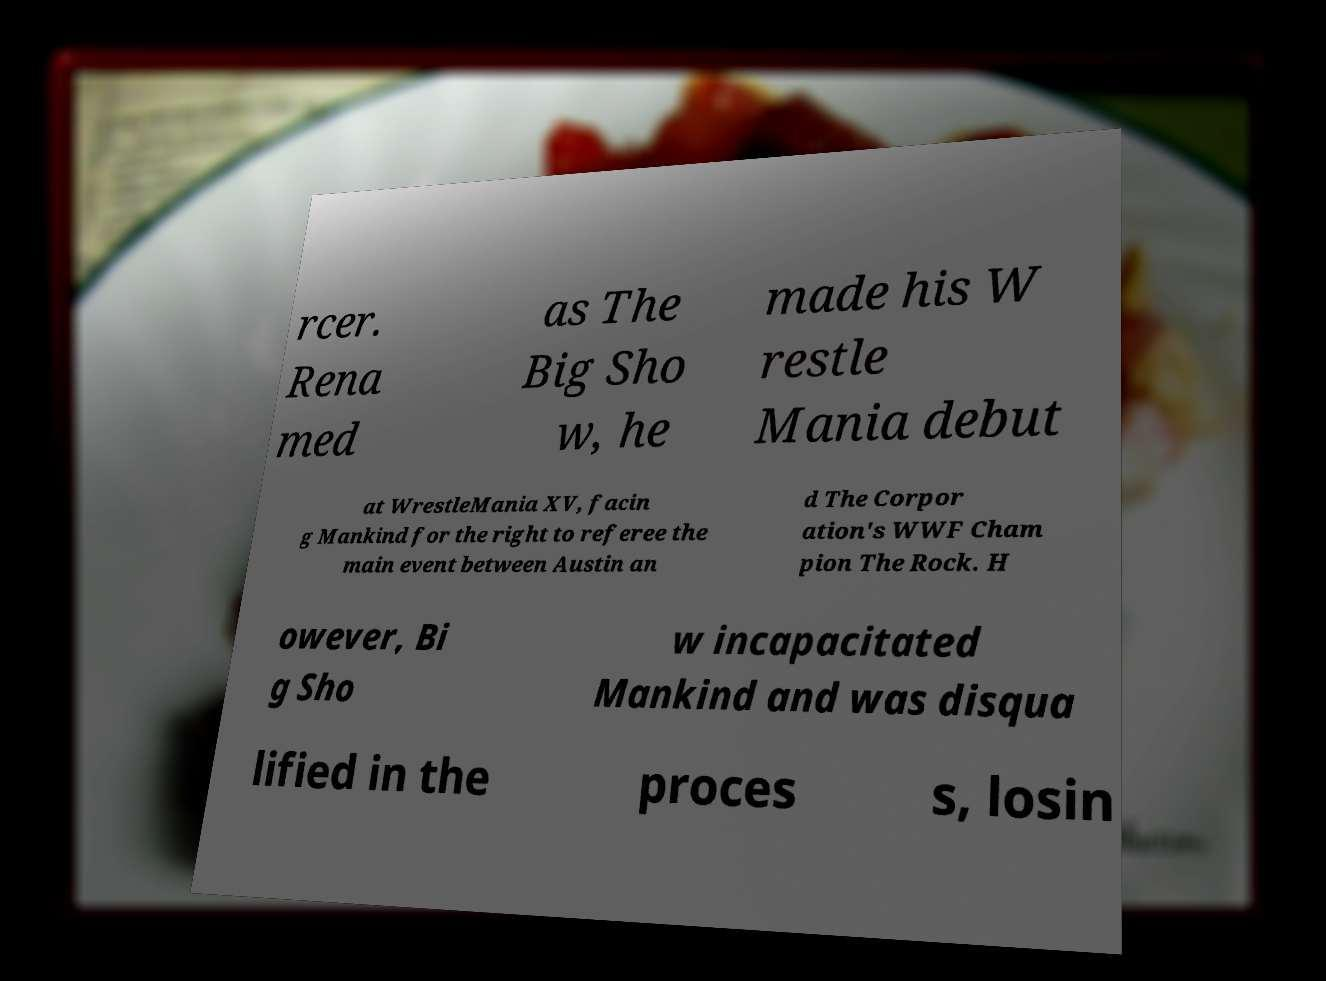For documentation purposes, I need the text within this image transcribed. Could you provide that? rcer. Rena med as The Big Sho w, he made his W restle Mania debut at WrestleMania XV, facin g Mankind for the right to referee the main event between Austin an d The Corpor ation's WWF Cham pion The Rock. H owever, Bi g Sho w incapacitated Mankind and was disqua lified in the proces s, losin 